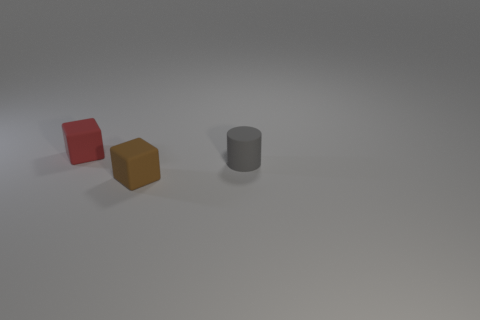Does the block that is to the right of the small red object have the same material as the thing that is behind the cylinder?
Keep it short and to the point. Yes. Is there a rubber thing?
Ensure brevity in your answer.  Yes. There is a tiny object behind the tiny gray rubber thing; does it have the same shape as the rubber object in front of the tiny rubber cylinder?
Provide a short and direct response. Yes. Is there a red object made of the same material as the gray object?
Your response must be concise. Yes. Is the small cube on the right side of the red rubber object made of the same material as the small gray cylinder?
Your response must be concise. Yes. Is the number of rubber cylinders that are in front of the tiny red thing greater than the number of tiny red matte things right of the small brown object?
Make the answer very short. Yes. There is a rubber cylinder that is the same size as the red cube; what is its color?
Your answer should be compact. Gray. There is a matte block that is on the right side of the red cube; is its color the same as the block that is to the left of the tiny brown rubber cube?
Offer a very short reply. No. There is a cube in front of the tiny red object; what is it made of?
Offer a very short reply. Rubber. There is a block that is made of the same material as the small red thing; what color is it?
Provide a succinct answer. Brown. 